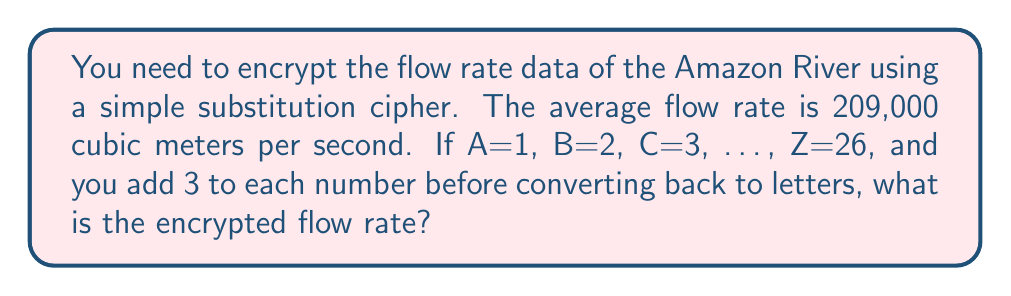Give your solution to this math problem. Let's approach this step-by-step:

1) First, we need to convert the flow rate 209,000 to letters:
   2 = B
   0 = (not represented in A-Z)
   9 = I

2) Now we have: BII,000

3) Next, we add 3 to each number representation:
   B (2) + 3 = 5
   I (9) + 3 = 12
   I (9) + 3 = 12

4) Now we convert these new numbers back to letters:
   5 = E
   12 = L
   12 = L

5) The zeros remain unchanged.

6) Therefore, the encrypted flow rate is: ELL,000

This simple substitution cipher shifts each letter forward by 3 in the alphabet, which is similar to the famous Caesar cipher.
Answer: ELL,000 